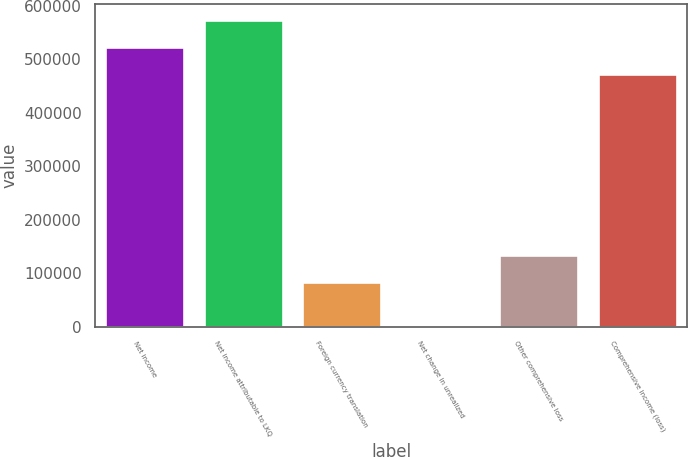Convert chart. <chart><loc_0><loc_0><loc_500><loc_500><bar_chart><fcel>Net income<fcel>Net income attributable to LKQ<fcel>Foreign currency translation<fcel>Net change in unrealized<fcel>Other comprehensive loss<fcel>Comprehensive income (loss)<nl><fcel>523289<fcel>573983<fcel>84090<fcel>697<fcel>134784<fcel>472595<nl></chart> 